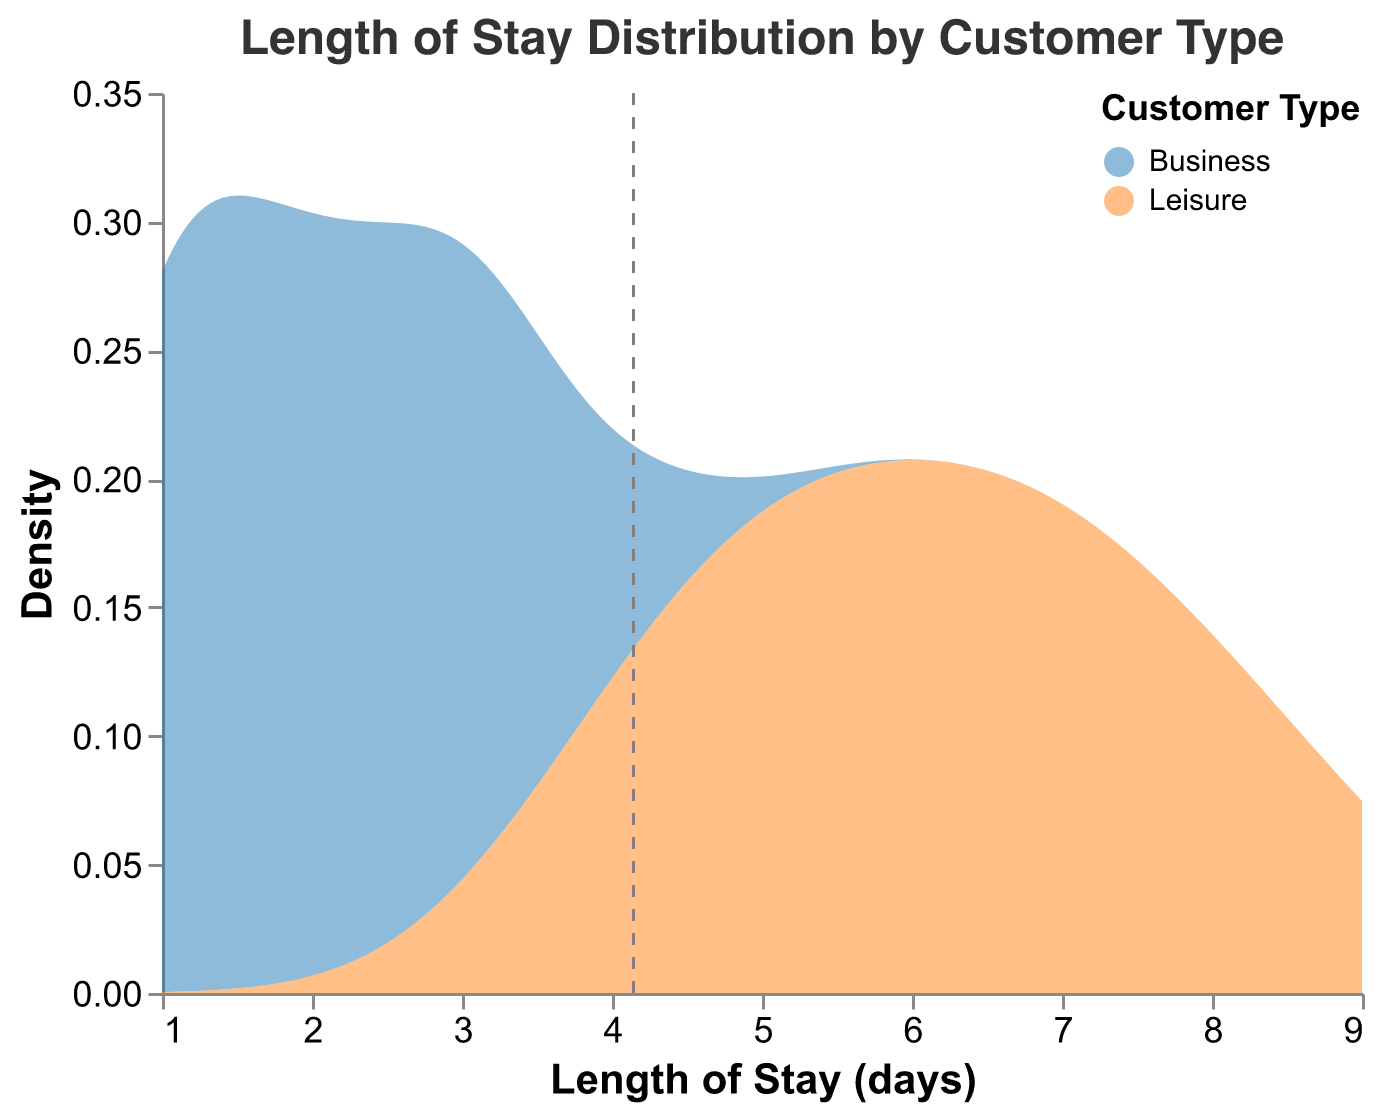What's the title of the figure? The title of the figure is displayed prominently at the top. It reads "Length of Stay Distribution by Customer Type".
Answer: Length of Stay Distribution by Customer Type What customer types are included in the plot? The plot legend and the color encoding indicate the customer types. There are two customer types: "Business" and "Leisure".
Answer: Business, Leisure What are the colors used to represent Business and Leisure customers? The legend shows the colors used for each customer type. Business customers are represented by blue, and Leisure customers by orange.
Answer: Blue, Orange Which customer type has a higher average length of stay? The plot includes a gray dashed line representing the mean length of stay for each customer type. Leisure customers have a higher mean, as indicated by their line located further to the right compared to Business customers.
Answer: Leisure How many distinct peaks are there in the density plot for Leisure customers? The density plot for Leisure customers shows a smooth curve with visible peaks. There are two distinct peaks.
Answer: 2 Which customer type shows a more varied length of stay? The spread and variation in the density plots help determine the variation. Leisure customers exhibit a wider range of lengths of stay compared to Business customers, whose distribution is more compact.
Answer: Leisure What's the most common length of stay for Business customers? The highest point on the density plot for Business customers indicates the mode. It appears around 1 day.
Answer: 1 Which customer type has a longer maximum length of stay as shown in the density plot? The density plot shows the range of lengths of stay. Leisure customers have the longest stay, stretching up to 9 days, while Business customers do not reach this value.
Answer: Leisure Are there any overlaps in the length of stay distributions between the two customer types? The density plots for both customer types can be examined to identify overlapping regions. Yes, there are overlaps, particularly in the lower ranges (around 4 days and below).
Answer: Yes What's the approximate density value for Leisure customers at a length of stay of 7 days? By looking at the density plot and following the y-axis at the 7-day mark, we can estimate the density value. It's around 0.13.
Answer: 0.13 